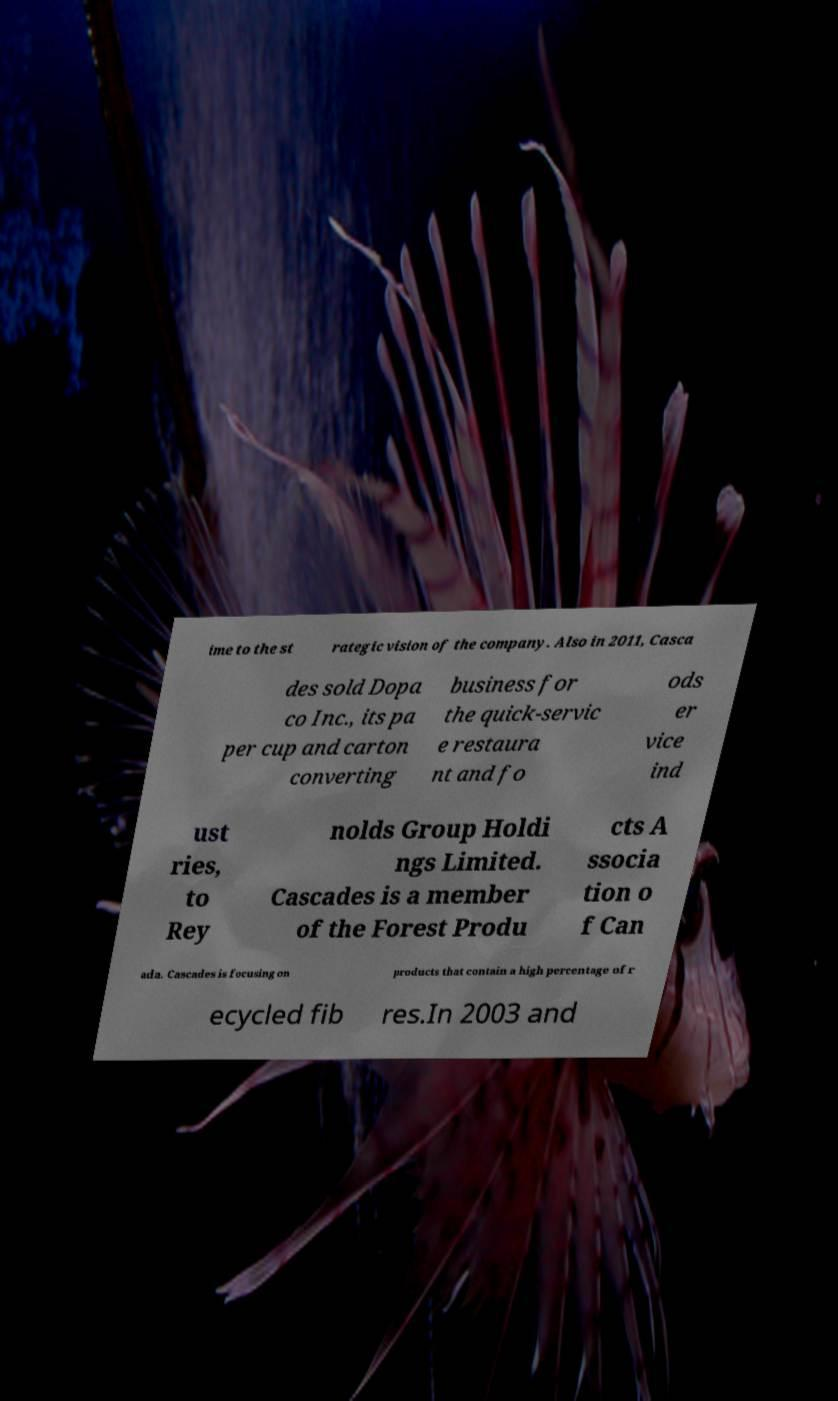Please read and relay the text visible in this image. What does it say? ime to the st rategic vision of the company. Also in 2011, Casca des sold Dopa co Inc., its pa per cup and carton converting business for the quick-servic e restaura nt and fo ods er vice ind ust ries, to Rey nolds Group Holdi ngs Limited. Cascades is a member of the Forest Produ cts A ssocia tion o f Can ada. Cascades is focusing on products that contain a high percentage of r ecycled fib res.In 2003 and 